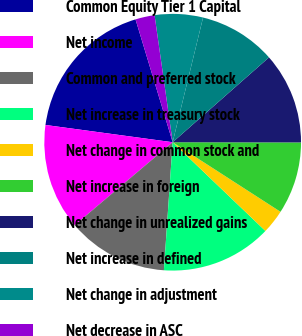Convert chart to OTSL. <chart><loc_0><loc_0><loc_500><loc_500><pie_chart><fcel>Common Equity Tier 1 Capital<fcel>Net income<fcel>Common and preferred stock<fcel>Net increase in treasury stock<fcel>Net change in common stock and<fcel>Net increase in foreign<fcel>Net change in unrealized gains<fcel>Net increase in defined<fcel>Net change in adjustment<fcel>Net decrease in ASC<nl><fcel>18.18%<fcel>13.33%<fcel>12.73%<fcel>13.94%<fcel>3.03%<fcel>9.09%<fcel>11.52%<fcel>9.7%<fcel>6.06%<fcel>2.42%<nl></chart> 